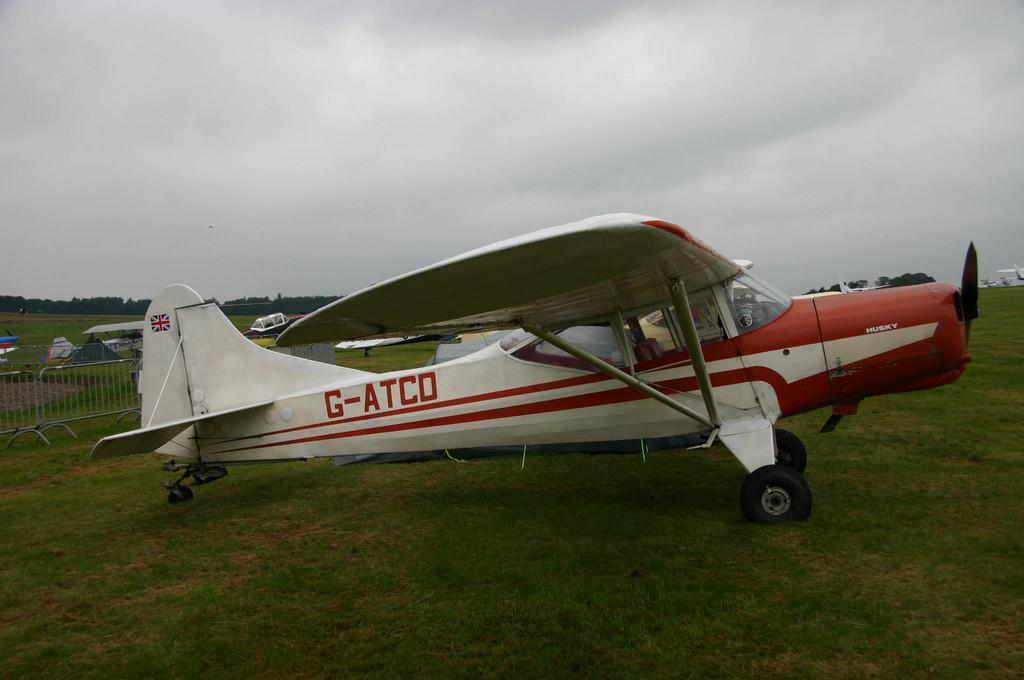<image>
Present a compact description of the photo's key features. A small red and white plane with call sign G-ATCO. 